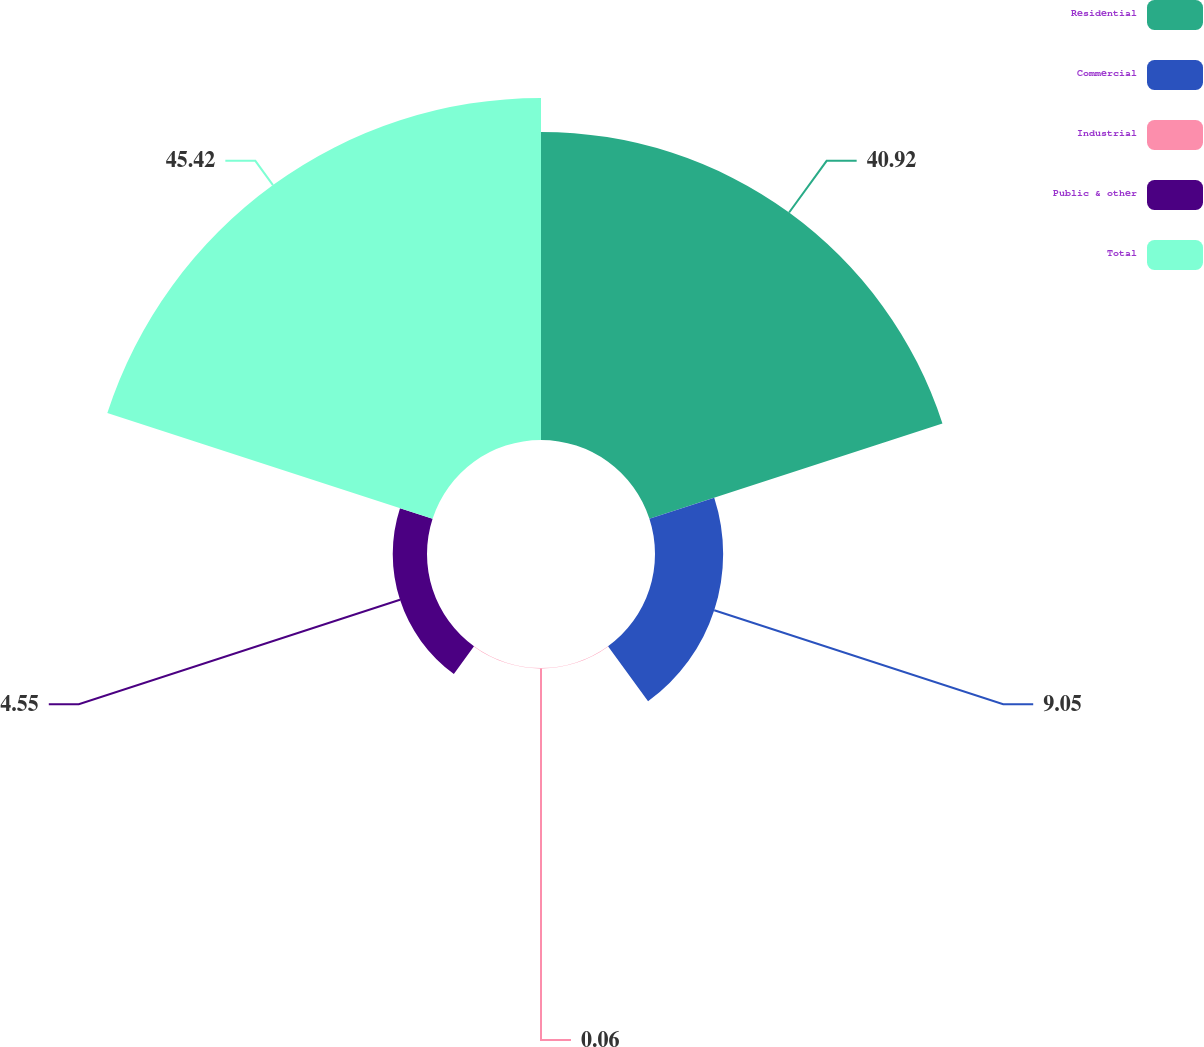<chart> <loc_0><loc_0><loc_500><loc_500><pie_chart><fcel>Residential<fcel>Commercial<fcel>Industrial<fcel>Public & other<fcel>Total<nl><fcel>40.92%<fcel>9.05%<fcel>0.06%<fcel>4.55%<fcel>45.42%<nl></chart> 